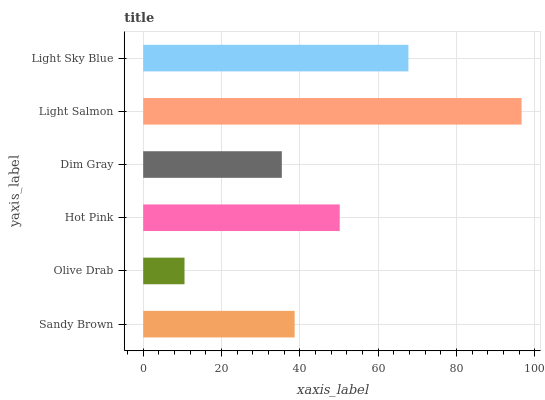Is Olive Drab the minimum?
Answer yes or no. Yes. Is Light Salmon the maximum?
Answer yes or no. Yes. Is Hot Pink the minimum?
Answer yes or no. No. Is Hot Pink the maximum?
Answer yes or no. No. Is Hot Pink greater than Olive Drab?
Answer yes or no. Yes. Is Olive Drab less than Hot Pink?
Answer yes or no. Yes. Is Olive Drab greater than Hot Pink?
Answer yes or no. No. Is Hot Pink less than Olive Drab?
Answer yes or no. No. Is Hot Pink the high median?
Answer yes or no. Yes. Is Sandy Brown the low median?
Answer yes or no. Yes. Is Olive Drab the high median?
Answer yes or no. No. Is Olive Drab the low median?
Answer yes or no. No. 